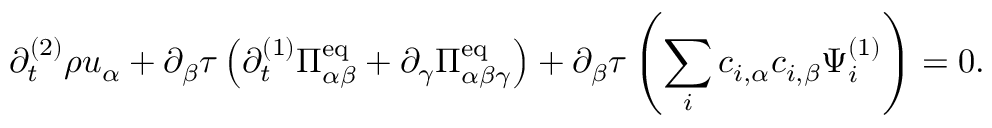Convert formula to latex. <formula><loc_0><loc_0><loc_500><loc_500>\partial _ { t } ^ { ( 2 ) } \rho u _ { \alpha } + \partial _ { \beta } \tau \left ( \partial _ { t } ^ { ( 1 ) } \Pi _ { \alpha \beta } ^ { e q } + \partial _ { \gamma } \Pi _ { \alpha \beta \gamma } ^ { e q } \right ) + \partial _ { \beta } \tau \left ( \sum _ { i } c _ { i , \alpha } c _ { i , \beta } \Psi _ { i } ^ { ( 1 ) } \right ) = 0 .</formula> 